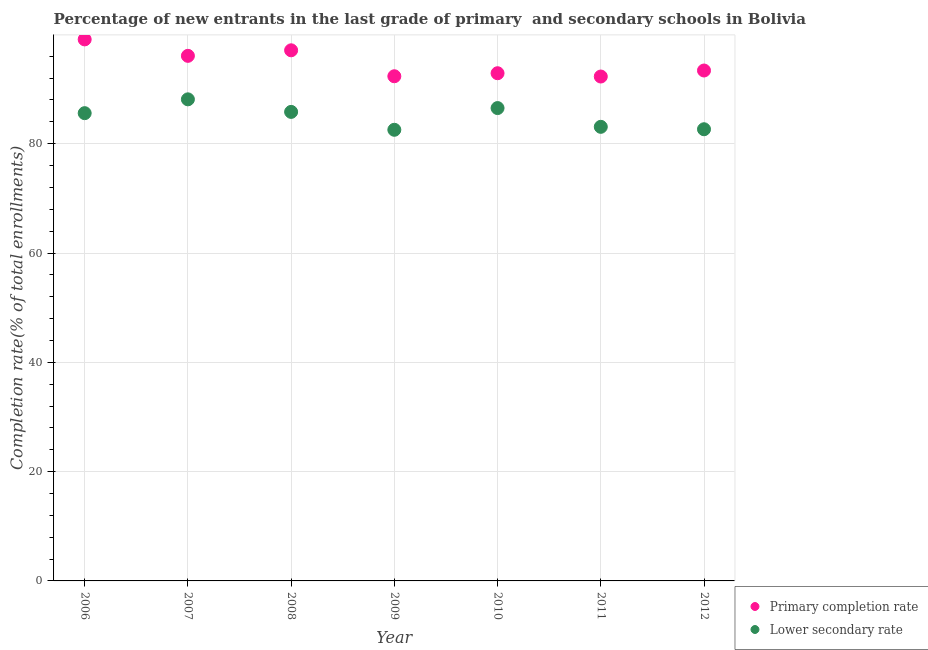How many different coloured dotlines are there?
Make the answer very short. 2. What is the completion rate in secondary schools in 2012?
Keep it short and to the point. 82.65. Across all years, what is the maximum completion rate in secondary schools?
Your answer should be compact. 88.12. Across all years, what is the minimum completion rate in primary schools?
Provide a short and direct response. 92.29. In which year was the completion rate in secondary schools maximum?
Give a very brief answer. 2007. In which year was the completion rate in secondary schools minimum?
Ensure brevity in your answer.  2009. What is the total completion rate in secondary schools in the graph?
Provide a short and direct response. 594.34. What is the difference between the completion rate in primary schools in 2006 and that in 2008?
Provide a succinct answer. 2. What is the difference between the completion rate in primary schools in 2011 and the completion rate in secondary schools in 2012?
Provide a succinct answer. 9.65. What is the average completion rate in primary schools per year?
Your answer should be very brief. 94.74. In the year 2008, what is the difference between the completion rate in secondary schools and completion rate in primary schools?
Give a very brief answer. -11.27. In how many years, is the completion rate in primary schools greater than 20 %?
Your answer should be very brief. 7. What is the ratio of the completion rate in secondary schools in 2006 to that in 2008?
Provide a succinct answer. 1. Is the completion rate in primary schools in 2006 less than that in 2011?
Your answer should be compact. No. What is the difference between the highest and the second highest completion rate in secondary schools?
Your response must be concise. 1.6. What is the difference between the highest and the lowest completion rate in secondary schools?
Ensure brevity in your answer.  5.57. In how many years, is the completion rate in secondary schools greater than the average completion rate in secondary schools taken over all years?
Keep it short and to the point. 4. Is the sum of the completion rate in primary schools in 2007 and 2008 greater than the maximum completion rate in secondary schools across all years?
Offer a terse response. Yes. Does the completion rate in secondary schools monotonically increase over the years?
Your response must be concise. No. Is the completion rate in primary schools strictly greater than the completion rate in secondary schools over the years?
Make the answer very short. Yes. Is the completion rate in secondary schools strictly less than the completion rate in primary schools over the years?
Give a very brief answer. Yes. What is the difference between two consecutive major ticks on the Y-axis?
Provide a short and direct response. 20. Are the values on the major ticks of Y-axis written in scientific E-notation?
Your response must be concise. No. Where does the legend appear in the graph?
Ensure brevity in your answer.  Bottom right. How many legend labels are there?
Provide a short and direct response. 2. How are the legend labels stacked?
Your answer should be very brief. Vertical. What is the title of the graph?
Keep it short and to the point. Percentage of new entrants in the last grade of primary  and secondary schools in Bolivia. Does "Net savings(excluding particulate emission damage)" appear as one of the legend labels in the graph?
Your response must be concise. No. What is the label or title of the X-axis?
Make the answer very short. Year. What is the label or title of the Y-axis?
Offer a terse response. Completion rate(% of total enrollments). What is the Completion rate(% of total enrollments) in Primary completion rate in 2006?
Provide a succinct answer. 99.09. What is the Completion rate(% of total enrollments) in Lower secondary rate in 2006?
Give a very brief answer. 85.59. What is the Completion rate(% of total enrollments) of Primary completion rate in 2007?
Provide a short and direct response. 96.08. What is the Completion rate(% of total enrollments) in Lower secondary rate in 2007?
Ensure brevity in your answer.  88.12. What is the Completion rate(% of total enrollments) in Primary completion rate in 2008?
Your response must be concise. 97.09. What is the Completion rate(% of total enrollments) in Lower secondary rate in 2008?
Provide a short and direct response. 85.82. What is the Completion rate(% of total enrollments) in Primary completion rate in 2009?
Your response must be concise. 92.35. What is the Completion rate(% of total enrollments) in Lower secondary rate in 2009?
Offer a very short reply. 82.55. What is the Completion rate(% of total enrollments) in Primary completion rate in 2010?
Provide a succinct answer. 92.9. What is the Completion rate(% of total enrollments) of Lower secondary rate in 2010?
Provide a succinct answer. 86.52. What is the Completion rate(% of total enrollments) of Primary completion rate in 2011?
Provide a succinct answer. 92.29. What is the Completion rate(% of total enrollments) of Lower secondary rate in 2011?
Your response must be concise. 83.09. What is the Completion rate(% of total enrollments) of Primary completion rate in 2012?
Offer a terse response. 93.4. What is the Completion rate(% of total enrollments) in Lower secondary rate in 2012?
Your response must be concise. 82.65. Across all years, what is the maximum Completion rate(% of total enrollments) of Primary completion rate?
Provide a succinct answer. 99.09. Across all years, what is the maximum Completion rate(% of total enrollments) of Lower secondary rate?
Ensure brevity in your answer.  88.12. Across all years, what is the minimum Completion rate(% of total enrollments) of Primary completion rate?
Make the answer very short. 92.29. Across all years, what is the minimum Completion rate(% of total enrollments) of Lower secondary rate?
Your answer should be very brief. 82.55. What is the total Completion rate(% of total enrollments) in Primary completion rate in the graph?
Ensure brevity in your answer.  663.19. What is the total Completion rate(% of total enrollments) of Lower secondary rate in the graph?
Your answer should be very brief. 594.34. What is the difference between the Completion rate(% of total enrollments) in Primary completion rate in 2006 and that in 2007?
Your answer should be compact. 3.01. What is the difference between the Completion rate(% of total enrollments) of Lower secondary rate in 2006 and that in 2007?
Give a very brief answer. -2.53. What is the difference between the Completion rate(% of total enrollments) of Primary completion rate in 2006 and that in 2008?
Offer a very short reply. 2. What is the difference between the Completion rate(% of total enrollments) of Lower secondary rate in 2006 and that in 2008?
Your answer should be very brief. -0.23. What is the difference between the Completion rate(% of total enrollments) of Primary completion rate in 2006 and that in 2009?
Provide a succinct answer. 6.74. What is the difference between the Completion rate(% of total enrollments) of Lower secondary rate in 2006 and that in 2009?
Your answer should be very brief. 3.04. What is the difference between the Completion rate(% of total enrollments) of Primary completion rate in 2006 and that in 2010?
Your response must be concise. 6.19. What is the difference between the Completion rate(% of total enrollments) of Lower secondary rate in 2006 and that in 2010?
Ensure brevity in your answer.  -0.93. What is the difference between the Completion rate(% of total enrollments) of Primary completion rate in 2006 and that in 2011?
Make the answer very short. 6.79. What is the difference between the Completion rate(% of total enrollments) of Lower secondary rate in 2006 and that in 2011?
Keep it short and to the point. 2.5. What is the difference between the Completion rate(% of total enrollments) of Primary completion rate in 2006 and that in 2012?
Offer a very short reply. 5.69. What is the difference between the Completion rate(% of total enrollments) in Lower secondary rate in 2006 and that in 2012?
Provide a short and direct response. 2.94. What is the difference between the Completion rate(% of total enrollments) of Primary completion rate in 2007 and that in 2008?
Offer a terse response. -1.01. What is the difference between the Completion rate(% of total enrollments) of Lower secondary rate in 2007 and that in 2008?
Make the answer very short. 2.3. What is the difference between the Completion rate(% of total enrollments) of Primary completion rate in 2007 and that in 2009?
Your response must be concise. 3.73. What is the difference between the Completion rate(% of total enrollments) in Lower secondary rate in 2007 and that in 2009?
Provide a succinct answer. 5.57. What is the difference between the Completion rate(% of total enrollments) of Primary completion rate in 2007 and that in 2010?
Provide a succinct answer. 3.18. What is the difference between the Completion rate(% of total enrollments) of Lower secondary rate in 2007 and that in 2010?
Give a very brief answer. 1.6. What is the difference between the Completion rate(% of total enrollments) in Primary completion rate in 2007 and that in 2011?
Offer a very short reply. 3.79. What is the difference between the Completion rate(% of total enrollments) of Lower secondary rate in 2007 and that in 2011?
Make the answer very short. 5.03. What is the difference between the Completion rate(% of total enrollments) of Primary completion rate in 2007 and that in 2012?
Ensure brevity in your answer.  2.68. What is the difference between the Completion rate(% of total enrollments) of Lower secondary rate in 2007 and that in 2012?
Keep it short and to the point. 5.47. What is the difference between the Completion rate(% of total enrollments) in Primary completion rate in 2008 and that in 2009?
Make the answer very short. 4.75. What is the difference between the Completion rate(% of total enrollments) in Lower secondary rate in 2008 and that in 2009?
Ensure brevity in your answer.  3.27. What is the difference between the Completion rate(% of total enrollments) of Primary completion rate in 2008 and that in 2010?
Your answer should be very brief. 4.19. What is the difference between the Completion rate(% of total enrollments) of Lower secondary rate in 2008 and that in 2010?
Ensure brevity in your answer.  -0.7. What is the difference between the Completion rate(% of total enrollments) of Primary completion rate in 2008 and that in 2011?
Provide a short and direct response. 4.8. What is the difference between the Completion rate(% of total enrollments) of Lower secondary rate in 2008 and that in 2011?
Your answer should be very brief. 2.73. What is the difference between the Completion rate(% of total enrollments) of Primary completion rate in 2008 and that in 2012?
Provide a succinct answer. 3.7. What is the difference between the Completion rate(% of total enrollments) of Lower secondary rate in 2008 and that in 2012?
Make the answer very short. 3.17. What is the difference between the Completion rate(% of total enrollments) of Primary completion rate in 2009 and that in 2010?
Offer a terse response. -0.55. What is the difference between the Completion rate(% of total enrollments) of Lower secondary rate in 2009 and that in 2010?
Give a very brief answer. -3.97. What is the difference between the Completion rate(% of total enrollments) of Primary completion rate in 2009 and that in 2011?
Provide a succinct answer. 0.05. What is the difference between the Completion rate(% of total enrollments) in Lower secondary rate in 2009 and that in 2011?
Provide a short and direct response. -0.54. What is the difference between the Completion rate(% of total enrollments) in Primary completion rate in 2009 and that in 2012?
Provide a short and direct response. -1.05. What is the difference between the Completion rate(% of total enrollments) in Lower secondary rate in 2009 and that in 2012?
Give a very brief answer. -0.1. What is the difference between the Completion rate(% of total enrollments) of Primary completion rate in 2010 and that in 2011?
Make the answer very short. 0.6. What is the difference between the Completion rate(% of total enrollments) in Lower secondary rate in 2010 and that in 2011?
Your response must be concise. 3.43. What is the difference between the Completion rate(% of total enrollments) in Primary completion rate in 2010 and that in 2012?
Offer a terse response. -0.5. What is the difference between the Completion rate(% of total enrollments) of Lower secondary rate in 2010 and that in 2012?
Ensure brevity in your answer.  3.87. What is the difference between the Completion rate(% of total enrollments) in Primary completion rate in 2011 and that in 2012?
Give a very brief answer. -1.1. What is the difference between the Completion rate(% of total enrollments) of Lower secondary rate in 2011 and that in 2012?
Make the answer very short. 0.44. What is the difference between the Completion rate(% of total enrollments) in Primary completion rate in 2006 and the Completion rate(% of total enrollments) in Lower secondary rate in 2007?
Make the answer very short. 10.97. What is the difference between the Completion rate(% of total enrollments) in Primary completion rate in 2006 and the Completion rate(% of total enrollments) in Lower secondary rate in 2008?
Your answer should be very brief. 13.27. What is the difference between the Completion rate(% of total enrollments) of Primary completion rate in 2006 and the Completion rate(% of total enrollments) of Lower secondary rate in 2009?
Keep it short and to the point. 16.54. What is the difference between the Completion rate(% of total enrollments) of Primary completion rate in 2006 and the Completion rate(% of total enrollments) of Lower secondary rate in 2010?
Provide a succinct answer. 12.57. What is the difference between the Completion rate(% of total enrollments) in Primary completion rate in 2006 and the Completion rate(% of total enrollments) in Lower secondary rate in 2011?
Make the answer very short. 16. What is the difference between the Completion rate(% of total enrollments) of Primary completion rate in 2006 and the Completion rate(% of total enrollments) of Lower secondary rate in 2012?
Your response must be concise. 16.44. What is the difference between the Completion rate(% of total enrollments) of Primary completion rate in 2007 and the Completion rate(% of total enrollments) of Lower secondary rate in 2008?
Provide a short and direct response. 10.26. What is the difference between the Completion rate(% of total enrollments) of Primary completion rate in 2007 and the Completion rate(% of total enrollments) of Lower secondary rate in 2009?
Keep it short and to the point. 13.53. What is the difference between the Completion rate(% of total enrollments) in Primary completion rate in 2007 and the Completion rate(% of total enrollments) in Lower secondary rate in 2010?
Offer a very short reply. 9.56. What is the difference between the Completion rate(% of total enrollments) of Primary completion rate in 2007 and the Completion rate(% of total enrollments) of Lower secondary rate in 2011?
Your answer should be very brief. 12.99. What is the difference between the Completion rate(% of total enrollments) of Primary completion rate in 2007 and the Completion rate(% of total enrollments) of Lower secondary rate in 2012?
Your answer should be very brief. 13.43. What is the difference between the Completion rate(% of total enrollments) of Primary completion rate in 2008 and the Completion rate(% of total enrollments) of Lower secondary rate in 2009?
Provide a short and direct response. 14.54. What is the difference between the Completion rate(% of total enrollments) of Primary completion rate in 2008 and the Completion rate(% of total enrollments) of Lower secondary rate in 2010?
Provide a succinct answer. 10.57. What is the difference between the Completion rate(% of total enrollments) of Primary completion rate in 2008 and the Completion rate(% of total enrollments) of Lower secondary rate in 2011?
Ensure brevity in your answer.  14. What is the difference between the Completion rate(% of total enrollments) in Primary completion rate in 2008 and the Completion rate(% of total enrollments) in Lower secondary rate in 2012?
Offer a very short reply. 14.45. What is the difference between the Completion rate(% of total enrollments) of Primary completion rate in 2009 and the Completion rate(% of total enrollments) of Lower secondary rate in 2010?
Make the answer very short. 5.82. What is the difference between the Completion rate(% of total enrollments) of Primary completion rate in 2009 and the Completion rate(% of total enrollments) of Lower secondary rate in 2011?
Give a very brief answer. 9.26. What is the difference between the Completion rate(% of total enrollments) of Primary completion rate in 2009 and the Completion rate(% of total enrollments) of Lower secondary rate in 2012?
Your answer should be very brief. 9.7. What is the difference between the Completion rate(% of total enrollments) of Primary completion rate in 2010 and the Completion rate(% of total enrollments) of Lower secondary rate in 2011?
Keep it short and to the point. 9.81. What is the difference between the Completion rate(% of total enrollments) of Primary completion rate in 2010 and the Completion rate(% of total enrollments) of Lower secondary rate in 2012?
Your response must be concise. 10.25. What is the difference between the Completion rate(% of total enrollments) in Primary completion rate in 2011 and the Completion rate(% of total enrollments) in Lower secondary rate in 2012?
Ensure brevity in your answer.  9.65. What is the average Completion rate(% of total enrollments) in Primary completion rate per year?
Your response must be concise. 94.74. What is the average Completion rate(% of total enrollments) of Lower secondary rate per year?
Make the answer very short. 84.91. In the year 2006, what is the difference between the Completion rate(% of total enrollments) in Primary completion rate and Completion rate(% of total enrollments) in Lower secondary rate?
Provide a short and direct response. 13.5. In the year 2007, what is the difference between the Completion rate(% of total enrollments) of Primary completion rate and Completion rate(% of total enrollments) of Lower secondary rate?
Your response must be concise. 7.96. In the year 2008, what is the difference between the Completion rate(% of total enrollments) of Primary completion rate and Completion rate(% of total enrollments) of Lower secondary rate?
Your answer should be compact. 11.27. In the year 2009, what is the difference between the Completion rate(% of total enrollments) of Primary completion rate and Completion rate(% of total enrollments) of Lower secondary rate?
Offer a terse response. 9.8. In the year 2010, what is the difference between the Completion rate(% of total enrollments) of Primary completion rate and Completion rate(% of total enrollments) of Lower secondary rate?
Offer a very short reply. 6.38. In the year 2011, what is the difference between the Completion rate(% of total enrollments) of Primary completion rate and Completion rate(% of total enrollments) of Lower secondary rate?
Make the answer very short. 9.2. In the year 2012, what is the difference between the Completion rate(% of total enrollments) of Primary completion rate and Completion rate(% of total enrollments) of Lower secondary rate?
Provide a succinct answer. 10.75. What is the ratio of the Completion rate(% of total enrollments) of Primary completion rate in 2006 to that in 2007?
Your answer should be compact. 1.03. What is the ratio of the Completion rate(% of total enrollments) of Lower secondary rate in 2006 to that in 2007?
Provide a succinct answer. 0.97. What is the ratio of the Completion rate(% of total enrollments) of Primary completion rate in 2006 to that in 2008?
Provide a short and direct response. 1.02. What is the ratio of the Completion rate(% of total enrollments) of Lower secondary rate in 2006 to that in 2008?
Offer a very short reply. 1. What is the ratio of the Completion rate(% of total enrollments) in Primary completion rate in 2006 to that in 2009?
Give a very brief answer. 1.07. What is the ratio of the Completion rate(% of total enrollments) in Lower secondary rate in 2006 to that in 2009?
Provide a succinct answer. 1.04. What is the ratio of the Completion rate(% of total enrollments) in Primary completion rate in 2006 to that in 2010?
Your answer should be compact. 1.07. What is the ratio of the Completion rate(% of total enrollments) of Lower secondary rate in 2006 to that in 2010?
Your answer should be very brief. 0.99. What is the ratio of the Completion rate(% of total enrollments) in Primary completion rate in 2006 to that in 2011?
Offer a very short reply. 1.07. What is the ratio of the Completion rate(% of total enrollments) of Lower secondary rate in 2006 to that in 2011?
Make the answer very short. 1.03. What is the ratio of the Completion rate(% of total enrollments) in Primary completion rate in 2006 to that in 2012?
Your answer should be compact. 1.06. What is the ratio of the Completion rate(% of total enrollments) of Lower secondary rate in 2006 to that in 2012?
Give a very brief answer. 1.04. What is the ratio of the Completion rate(% of total enrollments) in Primary completion rate in 2007 to that in 2008?
Your answer should be very brief. 0.99. What is the ratio of the Completion rate(% of total enrollments) in Lower secondary rate in 2007 to that in 2008?
Make the answer very short. 1.03. What is the ratio of the Completion rate(% of total enrollments) in Primary completion rate in 2007 to that in 2009?
Your answer should be compact. 1.04. What is the ratio of the Completion rate(% of total enrollments) in Lower secondary rate in 2007 to that in 2009?
Provide a short and direct response. 1.07. What is the ratio of the Completion rate(% of total enrollments) in Primary completion rate in 2007 to that in 2010?
Make the answer very short. 1.03. What is the ratio of the Completion rate(% of total enrollments) of Lower secondary rate in 2007 to that in 2010?
Your answer should be very brief. 1.02. What is the ratio of the Completion rate(% of total enrollments) in Primary completion rate in 2007 to that in 2011?
Give a very brief answer. 1.04. What is the ratio of the Completion rate(% of total enrollments) of Lower secondary rate in 2007 to that in 2011?
Ensure brevity in your answer.  1.06. What is the ratio of the Completion rate(% of total enrollments) of Primary completion rate in 2007 to that in 2012?
Ensure brevity in your answer.  1.03. What is the ratio of the Completion rate(% of total enrollments) of Lower secondary rate in 2007 to that in 2012?
Provide a short and direct response. 1.07. What is the ratio of the Completion rate(% of total enrollments) of Primary completion rate in 2008 to that in 2009?
Provide a short and direct response. 1.05. What is the ratio of the Completion rate(% of total enrollments) of Lower secondary rate in 2008 to that in 2009?
Your answer should be very brief. 1.04. What is the ratio of the Completion rate(% of total enrollments) of Primary completion rate in 2008 to that in 2010?
Your response must be concise. 1.05. What is the ratio of the Completion rate(% of total enrollments) in Lower secondary rate in 2008 to that in 2010?
Provide a succinct answer. 0.99. What is the ratio of the Completion rate(% of total enrollments) of Primary completion rate in 2008 to that in 2011?
Give a very brief answer. 1.05. What is the ratio of the Completion rate(% of total enrollments) of Lower secondary rate in 2008 to that in 2011?
Give a very brief answer. 1.03. What is the ratio of the Completion rate(% of total enrollments) in Primary completion rate in 2008 to that in 2012?
Give a very brief answer. 1.04. What is the ratio of the Completion rate(% of total enrollments) in Lower secondary rate in 2008 to that in 2012?
Your answer should be very brief. 1.04. What is the ratio of the Completion rate(% of total enrollments) of Lower secondary rate in 2009 to that in 2010?
Your answer should be very brief. 0.95. What is the ratio of the Completion rate(% of total enrollments) of Primary completion rate in 2009 to that in 2012?
Provide a succinct answer. 0.99. What is the ratio of the Completion rate(% of total enrollments) in Lower secondary rate in 2009 to that in 2012?
Make the answer very short. 1. What is the ratio of the Completion rate(% of total enrollments) in Primary completion rate in 2010 to that in 2011?
Offer a terse response. 1.01. What is the ratio of the Completion rate(% of total enrollments) of Lower secondary rate in 2010 to that in 2011?
Your answer should be very brief. 1.04. What is the ratio of the Completion rate(% of total enrollments) in Primary completion rate in 2010 to that in 2012?
Your answer should be very brief. 0.99. What is the ratio of the Completion rate(% of total enrollments) in Lower secondary rate in 2010 to that in 2012?
Offer a terse response. 1.05. What is the difference between the highest and the second highest Completion rate(% of total enrollments) in Primary completion rate?
Make the answer very short. 2. What is the difference between the highest and the second highest Completion rate(% of total enrollments) of Lower secondary rate?
Make the answer very short. 1.6. What is the difference between the highest and the lowest Completion rate(% of total enrollments) in Primary completion rate?
Your answer should be very brief. 6.79. What is the difference between the highest and the lowest Completion rate(% of total enrollments) in Lower secondary rate?
Your response must be concise. 5.57. 